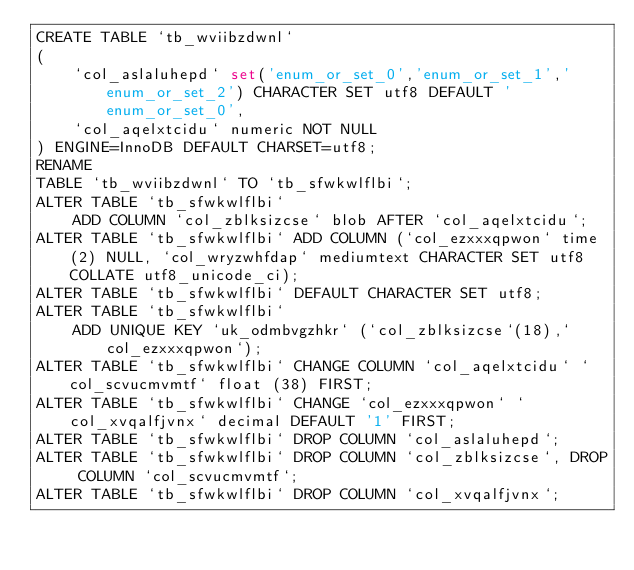<code> <loc_0><loc_0><loc_500><loc_500><_SQL_>CREATE TABLE `tb_wviibzdwnl`
(
    `col_aslaluhepd` set('enum_or_set_0','enum_or_set_1','enum_or_set_2') CHARACTER SET utf8 DEFAULT 'enum_or_set_0',
    `col_aqelxtcidu` numeric NOT NULL
) ENGINE=InnoDB DEFAULT CHARSET=utf8;
RENAME
TABLE `tb_wviibzdwnl` TO `tb_sfwkwlflbi`;
ALTER TABLE `tb_sfwkwlflbi`
    ADD COLUMN `col_zblksizcse` blob AFTER `col_aqelxtcidu`;
ALTER TABLE `tb_sfwkwlflbi` ADD COLUMN (`col_ezxxxqpwon` time(2) NULL, `col_wryzwhfdap` mediumtext CHARACTER SET utf8 COLLATE utf8_unicode_ci);
ALTER TABLE `tb_sfwkwlflbi` DEFAULT CHARACTER SET utf8;
ALTER TABLE `tb_sfwkwlflbi`
    ADD UNIQUE KEY `uk_odmbvgzhkr` (`col_zblksizcse`(18),`col_ezxxxqpwon`);
ALTER TABLE `tb_sfwkwlflbi` CHANGE COLUMN `col_aqelxtcidu` `col_scvucmvmtf` float (38) FIRST;
ALTER TABLE `tb_sfwkwlflbi` CHANGE `col_ezxxxqpwon` `col_xvqalfjvnx` decimal DEFAULT '1' FIRST;
ALTER TABLE `tb_sfwkwlflbi` DROP COLUMN `col_aslaluhepd`;
ALTER TABLE `tb_sfwkwlflbi` DROP COLUMN `col_zblksizcse`, DROP COLUMN `col_scvucmvmtf`;
ALTER TABLE `tb_sfwkwlflbi` DROP COLUMN `col_xvqalfjvnx`;
</code> 